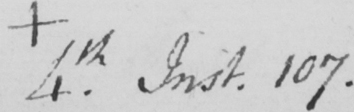Please transcribe the handwritten text in this image. +  4th . Inst . 107 . 